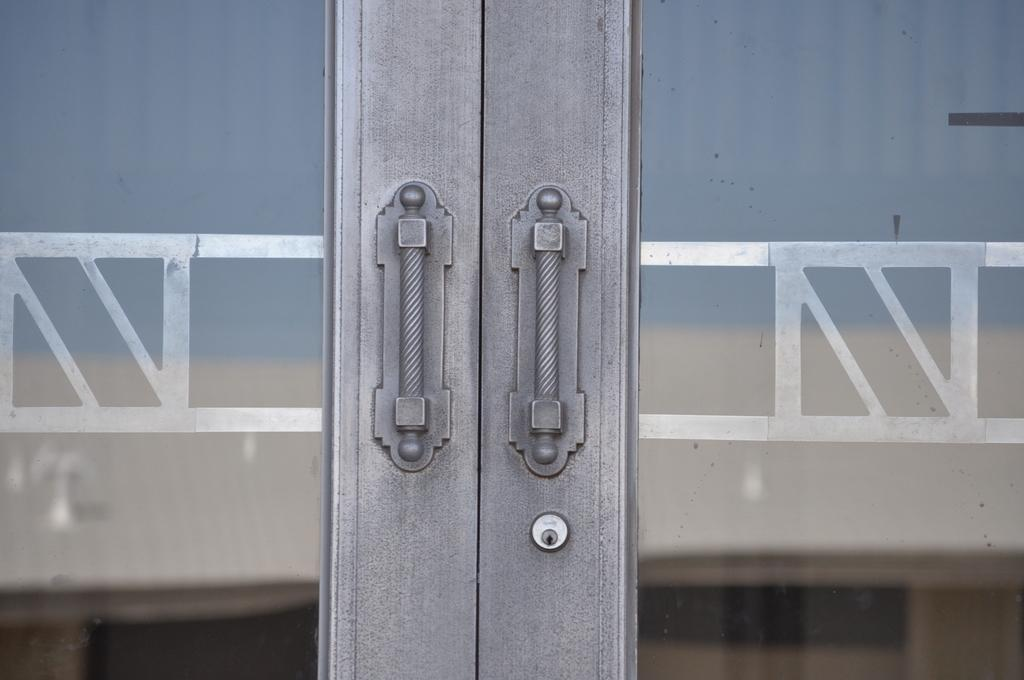What is located in the foreground of the picture? There is a door in the foreground of the picture. What is on the other side of the door? There is a wall on the other side of the door. What type of frame is visible around the door in the image? There is no frame visible around the door in the image. What kind of tank is present in the image? There is no tank present in the image. 